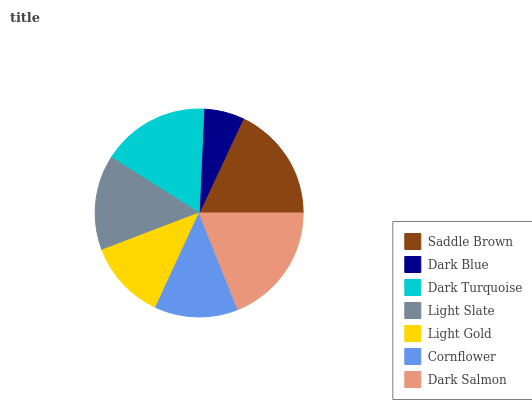Is Dark Blue the minimum?
Answer yes or no. Yes. Is Dark Salmon the maximum?
Answer yes or no. Yes. Is Dark Turquoise the minimum?
Answer yes or no. No. Is Dark Turquoise the maximum?
Answer yes or no. No. Is Dark Turquoise greater than Dark Blue?
Answer yes or no. Yes. Is Dark Blue less than Dark Turquoise?
Answer yes or no. Yes. Is Dark Blue greater than Dark Turquoise?
Answer yes or no. No. Is Dark Turquoise less than Dark Blue?
Answer yes or no. No. Is Light Slate the high median?
Answer yes or no. Yes. Is Light Slate the low median?
Answer yes or no. Yes. Is Saddle Brown the high median?
Answer yes or no. No. Is Dark Salmon the low median?
Answer yes or no. No. 